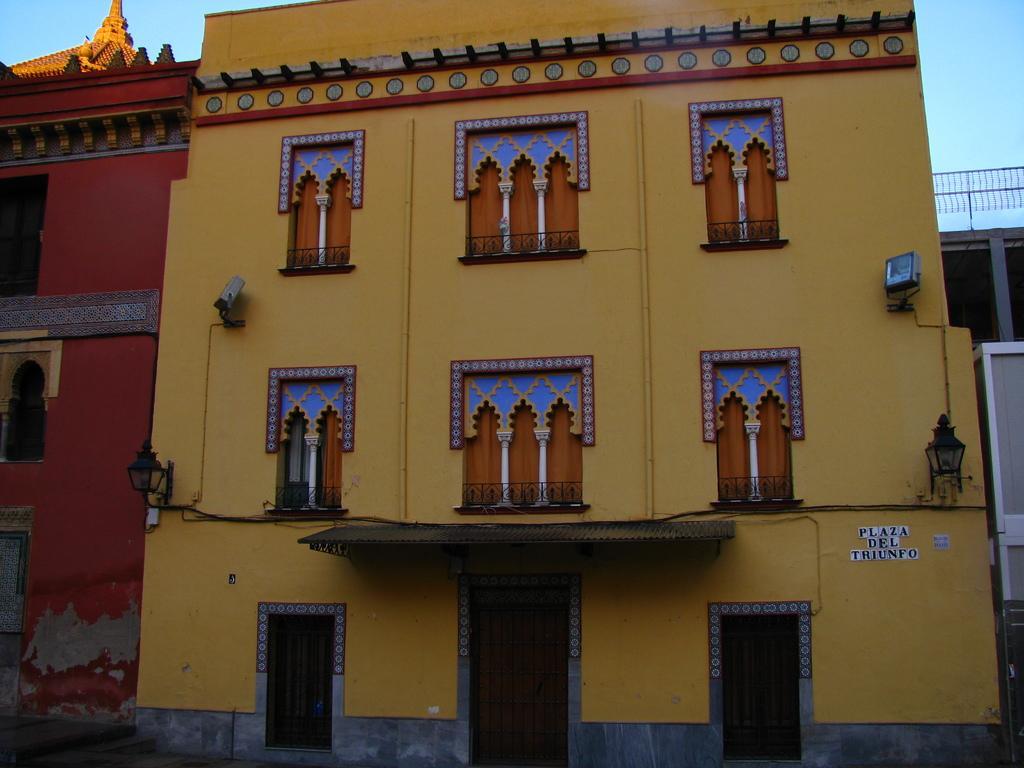In one or two sentences, can you explain what this image depicts? In this image I can see the buildings with windows and lights. I can see these buildings are in yellow, red and blue color. In the background I can see the sky. 